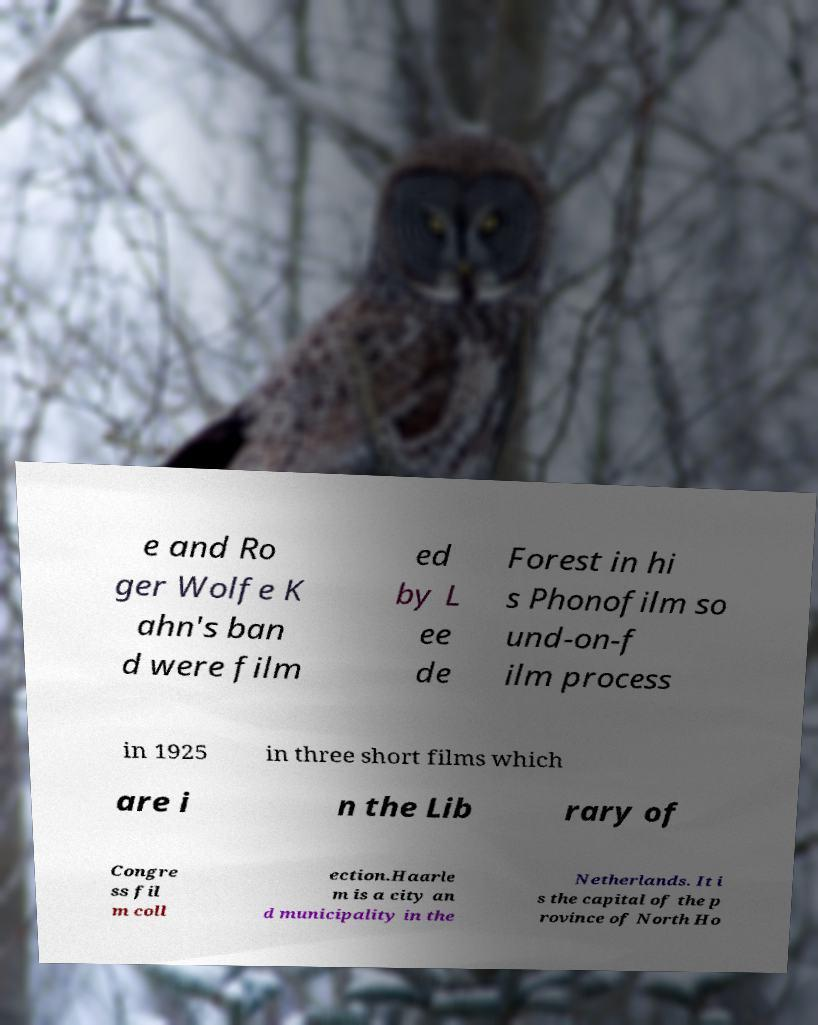For documentation purposes, I need the text within this image transcribed. Could you provide that? e and Ro ger Wolfe K ahn's ban d were film ed by L ee de Forest in hi s Phonofilm so und-on-f ilm process in 1925 in three short films which are i n the Lib rary of Congre ss fil m coll ection.Haarle m is a city an d municipality in the Netherlands. It i s the capital of the p rovince of North Ho 